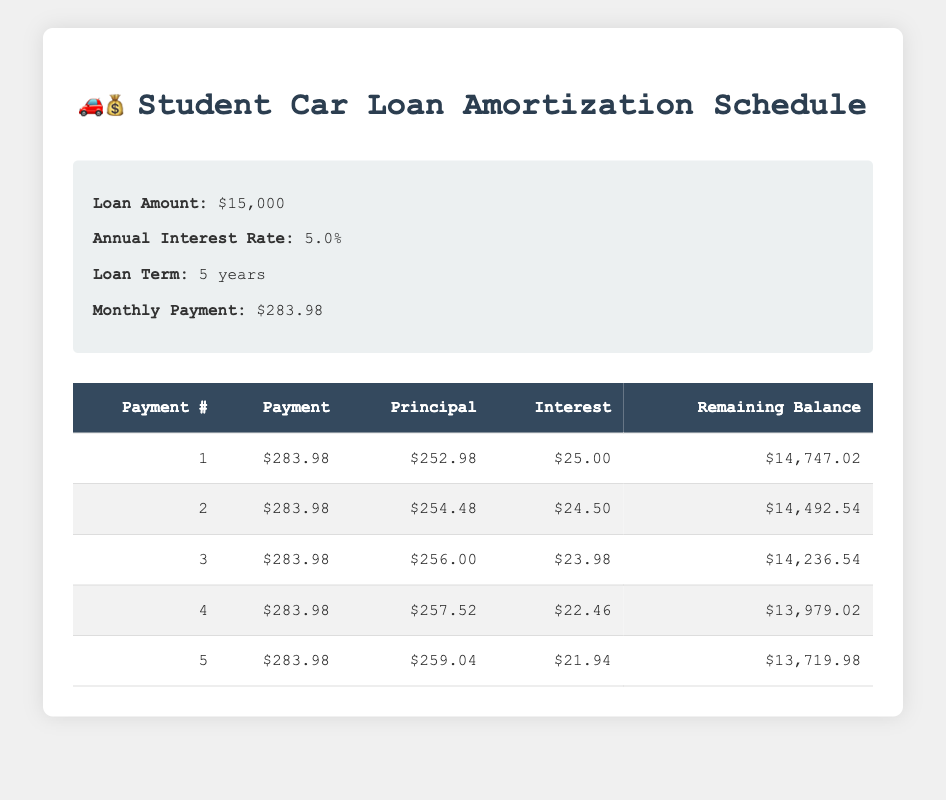What is the total amount of interest paid in the first payment? From the first row of the table, the interest paid in the first payment is listed as $25.00. Therefore, the total amount of interest paid in the first payment is simply this value.
Answer: 25.00 How much principal is paid off in the second payment? In the second row of the table, the principal paid off in the second payment is listed as $254.48. Thus, the answer directly comes from that value.
Answer: 254.48 What is the remaining balance after the third payment? After the third payment, the remaining balance is provided in the table as $14,236.54. This can be found directly in the third row.
Answer: 14,236.54 Is the interest paid in the fourth payment higher than the interest paid in the second payment? The interest for the fourth payment is $22.46 (from the fourth row) and the interest for the second payment is $24.50 (from the second row). Since $22.46 is less than $24.50, the statement is false.
Answer: No What is the total amount paid in principal after the first five payments? To find the total principal paid after the first five payments, we can add the principal amounts from each of the first five rows: (252.98 + 254.48 + 256.00 + 257.52 + 259.04) = 1,280.02. Therefore, the total principal amount is $1,280.02.
Answer: 1,280.02 What is the average monthly payment amount for the first five payments? The monthly payment is fixed at $283.98 as stated in the loan details. Since all five payments are the same, the average monthly payment is simply $283.98.
Answer: 283.98 What is the decrease in the remaining balance from the first payment to the fifth payment? The remaining balance after the first payment is $14,747.02, and the remaining balance after the fifth payment is $13,719.98. The decrease can be calculated as: $14,747.02 - $13,719.98 = $1,027.04.
Answer: 1,027.04 Is the principal paid in the first payment greater than the principal paid in the fourth payment? The principal paid in the first payment is $252.98 (from the first row) and the principal paid in the fourth payment is $257.52 (from the fourth row). Since $252.98 is less than $257.52, the statement is false.
Answer: No How much interest is paid over the first five payments? To find the total interest paid over the first five payments, we add the interest amounts from each of the five payments: (25.00 + 24.50 + 23.98 + 22.46 + 21.94) = 117.88. Thus, the total interest paid is $117.88.
Answer: 117.88 